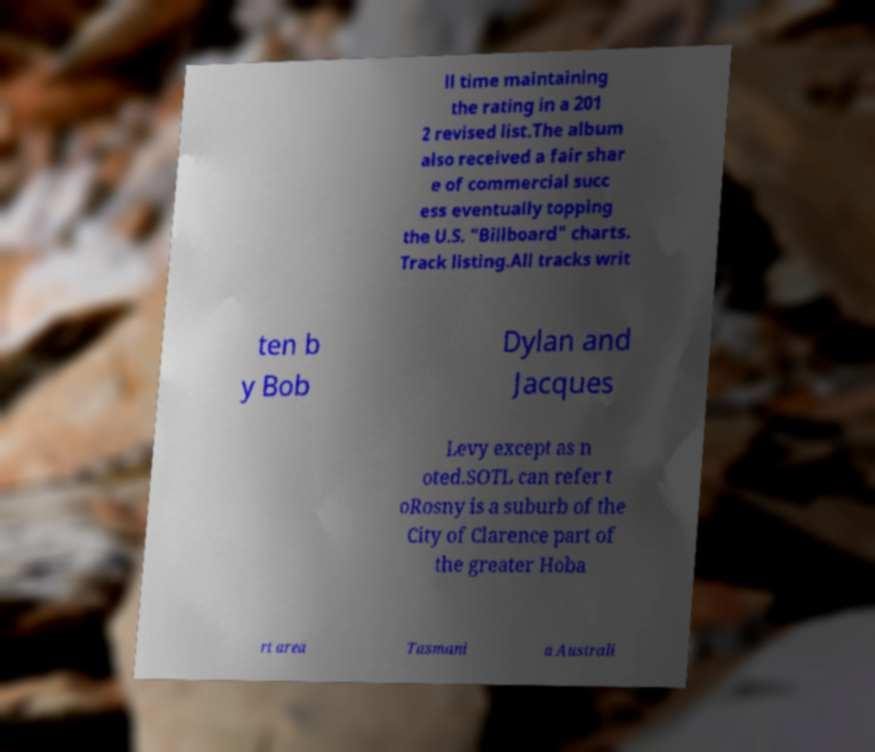Can you accurately transcribe the text from the provided image for me? ll time maintaining the rating in a 201 2 revised list.The album also received a fair shar e of commercial succ ess eventually topping the U.S. "Billboard" charts. Track listing.All tracks writ ten b y Bob Dylan and Jacques Levy except as n oted.SOTL can refer t oRosny is a suburb of the City of Clarence part of the greater Hoba rt area Tasmani a Australi 